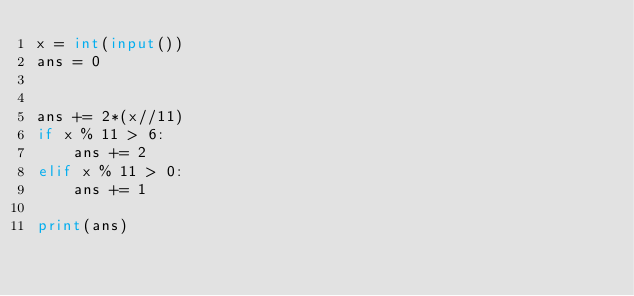Convert code to text. <code><loc_0><loc_0><loc_500><loc_500><_Python_>x = int(input())
ans = 0


ans += 2*(x//11)
if x % 11 > 6:
	ans += 2
elif x % 11 > 0:
	ans += 1

print(ans)</code> 